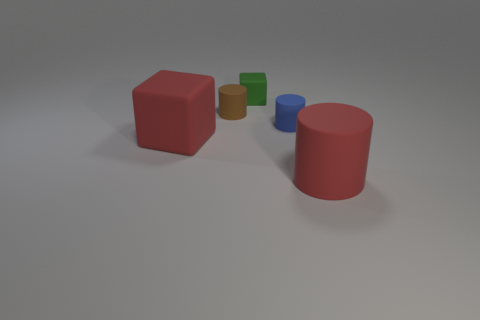What shape is the big thing that is the same color as the big matte cylinder?
Give a very brief answer. Cube. Does the green block have the same size as the blue cylinder?
Your response must be concise. Yes. Are any red rubber objects visible?
Give a very brief answer. Yes. There is a rubber thing that is the same color as the large cylinder; what size is it?
Ensure brevity in your answer.  Large. There is a matte cube that is left of the small matte object that is to the left of the tiny rubber object behind the small brown matte thing; what size is it?
Give a very brief answer. Large. What number of objects are made of the same material as the green cube?
Ensure brevity in your answer.  4. What number of brown matte cylinders have the same size as the blue rubber cylinder?
Offer a very short reply. 1. What material is the red thing that is left of the rubber cylinder that is on the right side of the tiny object that is in front of the brown object?
Offer a very short reply. Rubber. How many objects are small red matte cylinders or small rubber cylinders?
Your answer should be compact. 2. Are there any other things that are made of the same material as the blue thing?
Give a very brief answer. Yes. 